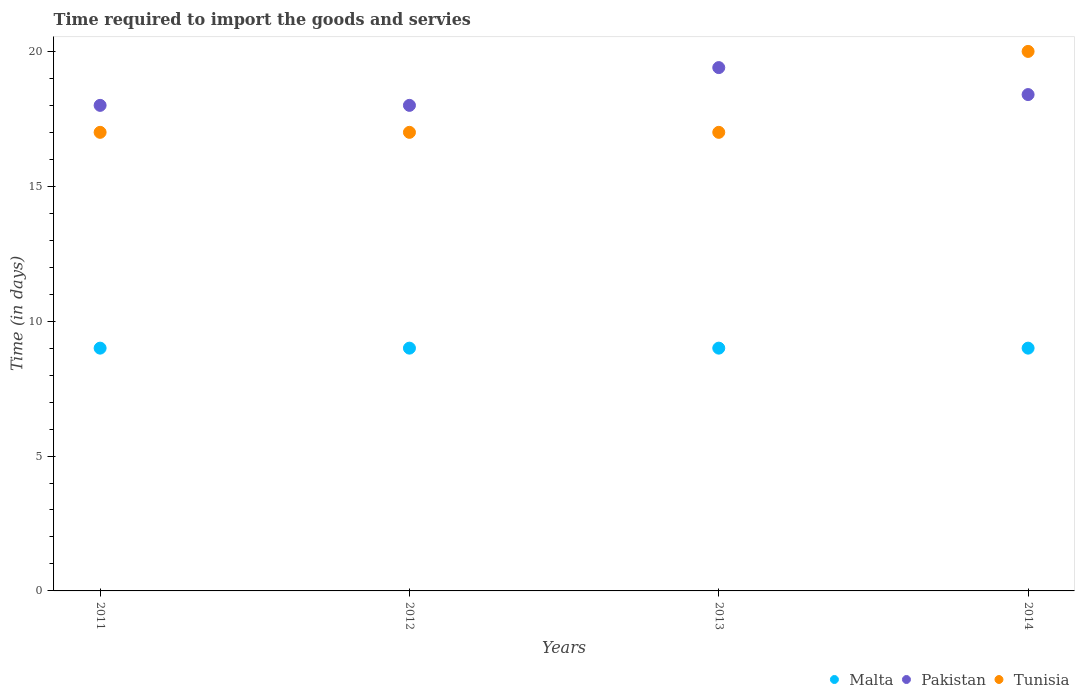How many different coloured dotlines are there?
Provide a short and direct response. 3. Is the number of dotlines equal to the number of legend labels?
Make the answer very short. Yes. Across all years, what is the maximum number of days required to import the goods and services in Tunisia?
Keep it short and to the point. 20. Across all years, what is the minimum number of days required to import the goods and services in Tunisia?
Keep it short and to the point. 17. What is the total number of days required to import the goods and services in Malta in the graph?
Offer a very short reply. 36. What is the average number of days required to import the goods and services in Malta per year?
Ensure brevity in your answer.  9. In the year 2013, what is the difference between the number of days required to import the goods and services in Tunisia and number of days required to import the goods and services in Pakistan?
Offer a terse response. -2.4. Is the number of days required to import the goods and services in Tunisia in 2011 less than that in 2014?
Make the answer very short. Yes. What is the difference between the highest and the second highest number of days required to import the goods and services in Malta?
Ensure brevity in your answer.  0. In how many years, is the number of days required to import the goods and services in Tunisia greater than the average number of days required to import the goods and services in Tunisia taken over all years?
Ensure brevity in your answer.  1. Is it the case that in every year, the sum of the number of days required to import the goods and services in Malta and number of days required to import the goods and services in Tunisia  is greater than the number of days required to import the goods and services in Pakistan?
Offer a very short reply. Yes. Is the number of days required to import the goods and services in Tunisia strictly greater than the number of days required to import the goods and services in Malta over the years?
Provide a succinct answer. Yes. How many dotlines are there?
Offer a terse response. 3. How many years are there in the graph?
Your response must be concise. 4. Does the graph contain any zero values?
Your answer should be very brief. No. What is the title of the graph?
Keep it short and to the point. Time required to import the goods and servies. What is the label or title of the Y-axis?
Provide a succinct answer. Time (in days). What is the Time (in days) in Malta in 2011?
Offer a terse response. 9. What is the Time (in days) in Pakistan in 2011?
Offer a very short reply. 18. What is the Time (in days) in Malta in 2012?
Make the answer very short. 9. What is the Time (in days) in Pakistan in 2012?
Your answer should be compact. 18. What is the Time (in days) of Tunisia in 2012?
Provide a short and direct response. 17. What is the Time (in days) of Pakistan in 2013?
Provide a short and direct response. 19.4. What is the Time (in days) of Pakistan in 2014?
Offer a terse response. 18.4. What is the Time (in days) in Tunisia in 2014?
Give a very brief answer. 20. Across all years, what is the maximum Time (in days) of Malta?
Offer a terse response. 9. What is the total Time (in days) of Pakistan in the graph?
Offer a terse response. 73.8. What is the difference between the Time (in days) in Malta in 2011 and that in 2012?
Keep it short and to the point. 0. What is the difference between the Time (in days) in Pakistan in 2011 and that in 2012?
Keep it short and to the point. 0. What is the difference between the Time (in days) in Tunisia in 2011 and that in 2013?
Provide a succinct answer. 0. What is the difference between the Time (in days) of Malta in 2011 and that in 2014?
Your response must be concise. 0. What is the difference between the Time (in days) in Malta in 2012 and that in 2014?
Make the answer very short. 0. What is the difference between the Time (in days) of Tunisia in 2012 and that in 2014?
Keep it short and to the point. -3. What is the difference between the Time (in days) of Malta in 2013 and that in 2014?
Offer a very short reply. 0. What is the difference between the Time (in days) in Pakistan in 2013 and that in 2014?
Provide a short and direct response. 1. What is the difference between the Time (in days) in Malta in 2011 and the Time (in days) in Tunisia in 2012?
Ensure brevity in your answer.  -8. What is the difference between the Time (in days) in Malta in 2011 and the Time (in days) in Pakistan in 2013?
Your response must be concise. -10.4. What is the difference between the Time (in days) in Malta in 2011 and the Time (in days) in Tunisia in 2013?
Ensure brevity in your answer.  -8. What is the difference between the Time (in days) of Pakistan in 2011 and the Time (in days) of Tunisia in 2013?
Your answer should be very brief. 1. What is the difference between the Time (in days) in Malta in 2011 and the Time (in days) in Tunisia in 2014?
Provide a short and direct response. -11. What is the difference between the Time (in days) in Pakistan in 2012 and the Time (in days) in Tunisia in 2013?
Provide a succinct answer. 1. What is the difference between the Time (in days) in Malta in 2013 and the Time (in days) in Pakistan in 2014?
Provide a short and direct response. -9.4. What is the average Time (in days) in Malta per year?
Make the answer very short. 9. What is the average Time (in days) of Pakistan per year?
Provide a short and direct response. 18.45. What is the average Time (in days) of Tunisia per year?
Provide a succinct answer. 17.75. In the year 2011, what is the difference between the Time (in days) in Malta and Time (in days) in Pakistan?
Offer a terse response. -9. In the year 2011, what is the difference between the Time (in days) in Malta and Time (in days) in Tunisia?
Your answer should be compact. -8. In the year 2011, what is the difference between the Time (in days) in Pakistan and Time (in days) in Tunisia?
Ensure brevity in your answer.  1. In the year 2012, what is the difference between the Time (in days) in Malta and Time (in days) in Tunisia?
Your answer should be compact. -8. In the year 2013, what is the difference between the Time (in days) of Malta and Time (in days) of Pakistan?
Provide a succinct answer. -10.4. In the year 2014, what is the difference between the Time (in days) of Malta and Time (in days) of Pakistan?
Your answer should be very brief. -9.4. In the year 2014, what is the difference between the Time (in days) of Malta and Time (in days) of Tunisia?
Ensure brevity in your answer.  -11. What is the ratio of the Time (in days) in Tunisia in 2011 to that in 2012?
Your answer should be compact. 1. What is the ratio of the Time (in days) of Pakistan in 2011 to that in 2013?
Give a very brief answer. 0.93. What is the ratio of the Time (in days) in Pakistan in 2011 to that in 2014?
Make the answer very short. 0.98. What is the ratio of the Time (in days) in Tunisia in 2011 to that in 2014?
Keep it short and to the point. 0.85. What is the ratio of the Time (in days) in Malta in 2012 to that in 2013?
Your answer should be very brief. 1. What is the ratio of the Time (in days) of Pakistan in 2012 to that in 2013?
Offer a terse response. 0.93. What is the ratio of the Time (in days) of Tunisia in 2012 to that in 2013?
Keep it short and to the point. 1. What is the ratio of the Time (in days) in Pakistan in 2012 to that in 2014?
Provide a short and direct response. 0.98. What is the ratio of the Time (in days) of Tunisia in 2012 to that in 2014?
Your response must be concise. 0.85. What is the ratio of the Time (in days) in Malta in 2013 to that in 2014?
Provide a short and direct response. 1. What is the ratio of the Time (in days) in Pakistan in 2013 to that in 2014?
Offer a terse response. 1.05. What is the difference between the highest and the second highest Time (in days) in Pakistan?
Provide a short and direct response. 1. What is the difference between the highest and the second highest Time (in days) in Tunisia?
Offer a terse response. 3. What is the difference between the highest and the lowest Time (in days) of Malta?
Offer a very short reply. 0. 